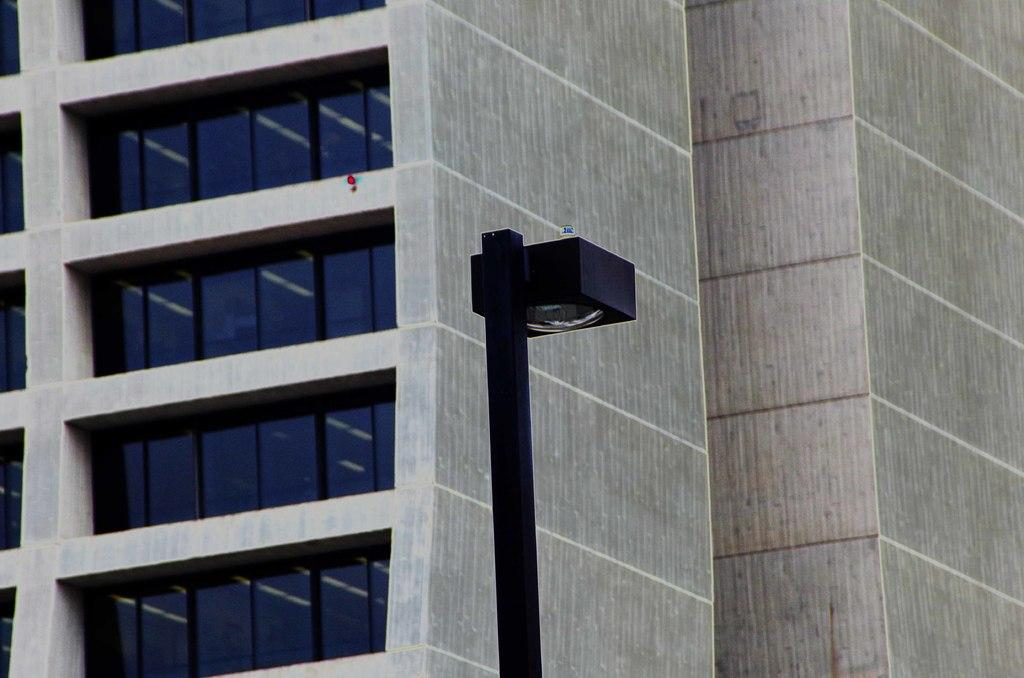What type of structure is visible in the image? There is a building in the image. What feature can be seen on the building? The building has windows. What else is present in the image besides the building? There is a pole in the image. What is attached to the pole? A lamp is present on the pole. Can you tell me how many cherries are on the book in the image? There is no book or cherries present in the image. 